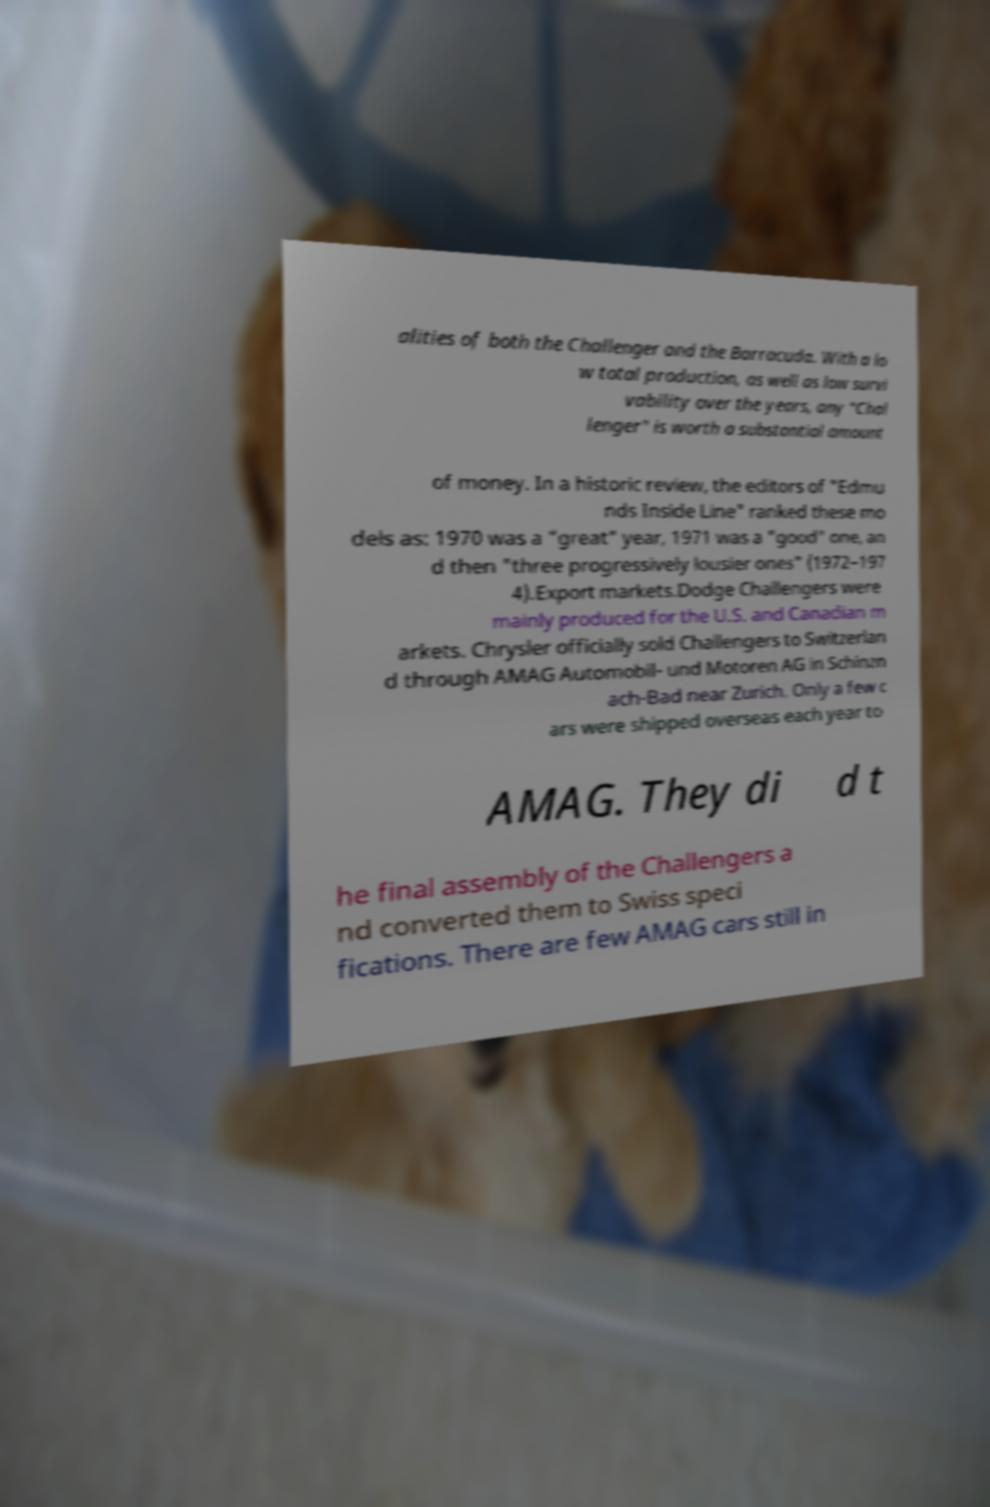Can you read and provide the text displayed in the image?This photo seems to have some interesting text. Can you extract and type it out for me? alities of both the Challenger and the Barracuda. With a lo w total production, as well as low survi vability over the years, any "Chal lenger" is worth a substantial amount of money. In a historic review, the editors of "Edmu nds Inside Line" ranked these mo dels as: 1970 was a "great" year, 1971 was a "good" one, an d then "three progressively lousier ones" (1972–197 4).Export markets.Dodge Challengers were mainly produced for the U.S. and Canadian m arkets. Chrysler officially sold Challengers to Switzerlan d through AMAG Automobil- und Motoren AG in Schinzn ach-Bad near Zurich. Only a few c ars were shipped overseas each year to AMAG. They di d t he final assembly of the Challengers a nd converted them to Swiss speci fications. There are few AMAG cars still in 